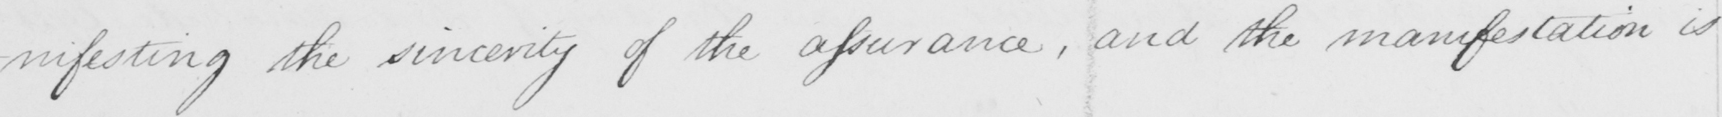Please transcribe the handwritten text in this image. -nifesting the sincerity of the assurance , and the manifestation is 